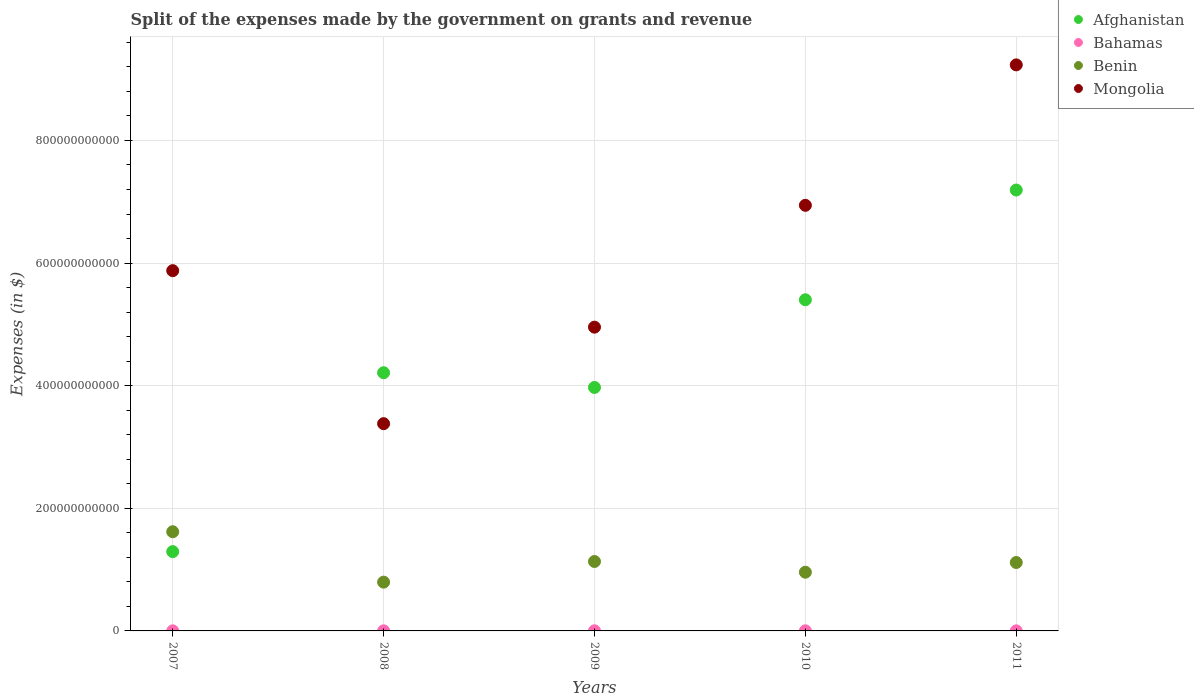How many different coloured dotlines are there?
Provide a succinct answer. 4. What is the expenses made by the government on grants and revenue in Mongolia in 2009?
Offer a very short reply. 4.95e+11. Across all years, what is the maximum expenses made by the government on grants and revenue in Benin?
Offer a very short reply. 1.62e+11. Across all years, what is the minimum expenses made by the government on grants and revenue in Benin?
Provide a short and direct response. 7.96e+1. What is the total expenses made by the government on grants and revenue in Mongolia in the graph?
Your response must be concise. 3.04e+12. What is the difference between the expenses made by the government on grants and revenue in Benin in 2008 and that in 2010?
Give a very brief answer. -1.62e+1. What is the difference between the expenses made by the government on grants and revenue in Afghanistan in 2008 and the expenses made by the government on grants and revenue in Bahamas in 2009?
Keep it short and to the point. 4.21e+11. What is the average expenses made by the government on grants and revenue in Benin per year?
Make the answer very short. 1.12e+11. In the year 2008, what is the difference between the expenses made by the government on grants and revenue in Mongolia and expenses made by the government on grants and revenue in Afghanistan?
Offer a terse response. -8.31e+1. In how many years, is the expenses made by the government on grants and revenue in Benin greater than 800000000000 $?
Offer a very short reply. 0. What is the ratio of the expenses made by the government on grants and revenue in Bahamas in 2007 to that in 2009?
Give a very brief answer. 0.67. What is the difference between the highest and the second highest expenses made by the government on grants and revenue in Afghanistan?
Your response must be concise. 1.79e+11. What is the difference between the highest and the lowest expenses made by the government on grants and revenue in Benin?
Your response must be concise. 8.22e+1. Is it the case that in every year, the sum of the expenses made by the government on grants and revenue in Mongolia and expenses made by the government on grants and revenue in Bahamas  is greater than the expenses made by the government on grants and revenue in Afghanistan?
Keep it short and to the point. No. Is the expenses made by the government on grants and revenue in Bahamas strictly less than the expenses made by the government on grants and revenue in Afghanistan over the years?
Make the answer very short. Yes. How many years are there in the graph?
Ensure brevity in your answer.  5. What is the difference between two consecutive major ticks on the Y-axis?
Make the answer very short. 2.00e+11. Does the graph contain any zero values?
Your answer should be very brief. No. Where does the legend appear in the graph?
Make the answer very short. Top right. How many legend labels are there?
Your answer should be compact. 4. How are the legend labels stacked?
Offer a terse response. Vertical. What is the title of the graph?
Your response must be concise. Split of the expenses made by the government on grants and revenue. Does "West Bank and Gaza" appear as one of the legend labels in the graph?
Your answer should be compact. No. What is the label or title of the X-axis?
Give a very brief answer. Years. What is the label or title of the Y-axis?
Offer a very short reply. Expenses (in $). What is the Expenses (in $) of Afghanistan in 2007?
Make the answer very short. 1.29e+11. What is the Expenses (in $) in Bahamas in 2007?
Give a very brief answer. 1.30e+08. What is the Expenses (in $) of Benin in 2007?
Make the answer very short. 1.62e+11. What is the Expenses (in $) in Mongolia in 2007?
Keep it short and to the point. 5.88e+11. What is the Expenses (in $) of Afghanistan in 2008?
Offer a terse response. 4.21e+11. What is the Expenses (in $) of Bahamas in 2008?
Your answer should be compact. 1.53e+08. What is the Expenses (in $) of Benin in 2008?
Offer a terse response. 7.96e+1. What is the Expenses (in $) of Mongolia in 2008?
Provide a short and direct response. 3.38e+11. What is the Expenses (in $) in Afghanistan in 2009?
Give a very brief answer. 3.97e+11. What is the Expenses (in $) in Bahamas in 2009?
Give a very brief answer. 1.93e+08. What is the Expenses (in $) in Benin in 2009?
Offer a very short reply. 1.13e+11. What is the Expenses (in $) of Mongolia in 2009?
Offer a very short reply. 4.95e+11. What is the Expenses (in $) in Afghanistan in 2010?
Offer a very short reply. 5.40e+11. What is the Expenses (in $) in Bahamas in 2010?
Your answer should be compact. 1.93e+08. What is the Expenses (in $) of Benin in 2010?
Offer a very short reply. 9.58e+1. What is the Expenses (in $) in Mongolia in 2010?
Keep it short and to the point. 6.94e+11. What is the Expenses (in $) in Afghanistan in 2011?
Make the answer very short. 7.19e+11. What is the Expenses (in $) in Bahamas in 2011?
Offer a very short reply. 1.35e+08. What is the Expenses (in $) in Benin in 2011?
Your answer should be compact. 1.12e+11. What is the Expenses (in $) of Mongolia in 2011?
Provide a short and direct response. 9.23e+11. Across all years, what is the maximum Expenses (in $) of Afghanistan?
Make the answer very short. 7.19e+11. Across all years, what is the maximum Expenses (in $) of Bahamas?
Your answer should be compact. 1.93e+08. Across all years, what is the maximum Expenses (in $) in Benin?
Offer a terse response. 1.62e+11. Across all years, what is the maximum Expenses (in $) in Mongolia?
Your response must be concise. 9.23e+11. Across all years, what is the minimum Expenses (in $) of Afghanistan?
Offer a very short reply. 1.29e+11. Across all years, what is the minimum Expenses (in $) of Bahamas?
Ensure brevity in your answer.  1.30e+08. Across all years, what is the minimum Expenses (in $) in Benin?
Your answer should be compact. 7.96e+1. Across all years, what is the minimum Expenses (in $) of Mongolia?
Give a very brief answer. 3.38e+11. What is the total Expenses (in $) of Afghanistan in the graph?
Provide a short and direct response. 2.21e+12. What is the total Expenses (in $) in Bahamas in the graph?
Make the answer very short. 8.04e+08. What is the total Expenses (in $) of Benin in the graph?
Your answer should be compact. 5.62e+11. What is the total Expenses (in $) of Mongolia in the graph?
Keep it short and to the point. 3.04e+12. What is the difference between the Expenses (in $) of Afghanistan in 2007 and that in 2008?
Your answer should be compact. -2.92e+11. What is the difference between the Expenses (in $) of Bahamas in 2007 and that in 2008?
Offer a terse response. -2.28e+07. What is the difference between the Expenses (in $) in Benin in 2007 and that in 2008?
Ensure brevity in your answer.  8.22e+1. What is the difference between the Expenses (in $) of Mongolia in 2007 and that in 2008?
Make the answer very short. 2.50e+11. What is the difference between the Expenses (in $) of Afghanistan in 2007 and that in 2009?
Provide a short and direct response. -2.68e+11. What is the difference between the Expenses (in $) of Bahamas in 2007 and that in 2009?
Offer a terse response. -6.33e+07. What is the difference between the Expenses (in $) of Benin in 2007 and that in 2009?
Provide a short and direct response. 4.85e+1. What is the difference between the Expenses (in $) in Mongolia in 2007 and that in 2009?
Ensure brevity in your answer.  9.22e+1. What is the difference between the Expenses (in $) of Afghanistan in 2007 and that in 2010?
Ensure brevity in your answer.  -4.11e+11. What is the difference between the Expenses (in $) in Bahamas in 2007 and that in 2010?
Keep it short and to the point. -6.31e+07. What is the difference between the Expenses (in $) of Benin in 2007 and that in 2010?
Your answer should be very brief. 6.60e+1. What is the difference between the Expenses (in $) of Mongolia in 2007 and that in 2010?
Offer a very short reply. -1.07e+11. What is the difference between the Expenses (in $) in Afghanistan in 2007 and that in 2011?
Offer a very short reply. -5.90e+11. What is the difference between the Expenses (in $) of Bahamas in 2007 and that in 2011?
Ensure brevity in your answer.  -5.26e+06. What is the difference between the Expenses (in $) in Benin in 2007 and that in 2011?
Provide a succinct answer. 5.02e+1. What is the difference between the Expenses (in $) of Mongolia in 2007 and that in 2011?
Offer a terse response. -3.36e+11. What is the difference between the Expenses (in $) of Afghanistan in 2008 and that in 2009?
Offer a very short reply. 2.40e+1. What is the difference between the Expenses (in $) in Bahamas in 2008 and that in 2009?
Give a very brief answer. -4.05e+07. What is the difference between the Expenses (in $) of Benin in 2008 and that in 2009?
Your answer should be compact. -3.37e+1. What is the difference between the Expenses (in $) in Mongolia in 2008 and that in 2009?
Your answer should be compact. -1.57e+11. What is the difference between the Expenses (in $) of Afghanistan in 2008 and that in 2010?
Provide a short and direct response. -1.19e+11. What is the difference between the Expenses (in $) in Bahamas in 2008 and that in 2010?
Your answer should be compact. -4.03e+07. What is the difference between the Expenses (in $) of Benin in 2008 and that in 2010?
Make the answer very short. -1.62e+1. What is the difference between the Expenses (in $) of Mongolia in 2008 and that in 2010?
Your response must be concise. -3.56e+11. What is the difference between the Expenses (in $) of Afghanistan in 2008 and that in 2011?
Your answer should be compact. -2.98e+11. What is the difference between the Expenses (in $) in Bahamas in 2008 and that in 2011?
Keep it short and to the point. 1.76e+07. What is the difference between the Expenses (in $) in Benin in 2008 and that in 2011?
Make the answer very short. -3.20e+1. What is the difference between the Expenses (in $) in Mongolia in 2008 and that in 2011?
Keep it short and to the point. -5.85e+11. What is the difference between the Expenses (in $) of Afghanistan in 2009 and that in 2010?
Provide a succinct answer. -1.43e+11. What is the difference between the Expenses (in $) in Bahamas in 2009 and that in 2010?
Your answer should be very brief. 1.93e+05. What is the difference between the Expenses (in $) in Benin in 2009 and that in 2010?
Offer a terse response. 1.75e+1. What is the difference between the Expenses (in $) in Mongolia in 2009 and that in 2010?
Give a very brief answer. -1.99e+11. What is the difference between the Expenses (in $) of Afghanistan in 2009 and that in 2011?
Give a very brief answer. -3.22e+11. What is the difference between the Expenses (in $) of Bahamas in 2009 and that in 2011?
Provide a succinct answer. 5.80e+07. What is the difference between the Expenses (in $) in Benin in 2009 and that in 2011?
Your answer should be very brief. 1.68e+09. What is the difference between the Expenses (in $) of Mongolia in 2009 and that in 2011?
Keep it short and to the point. -4.28e+11. What is the difference between the Expenses (in $) of Afghanistan in 2010 and that in 2011?
Keep it short and to the point. -1.79e+11. What is the difference between the Expenses (in $) in Bahamas in 2010 and that in 2011?
Ensure brevity in your answer.  5.79e+07. What is the difference between the Expenses (in $) of Benin in 2010 and that in 2011?
Offer a very short reply. -1.58e+1. What is the difference between the Expenses (in $) in Mongolia in 2010 and that in 2011?
Give a very brief answer. -2.29e+11. What is the difference between the Expenses (in $) in Afghanistan in 2007 and the Expenses (in $) in Bahamas in 2008?
Your answer should be compact. 1.29e+11. What is the difference between the Expenses (in $) in Afghanistan in 2007 and the Expenses (in $) in Benin in 2008?
Offer a terse response. 4.98e+1. What is the difference between the Expenses (in $) of Afghanistan in 2007 and the Expenses (in $) of Mongolia in 2008?
Your answer should be very brief. -2.09e+11. What is the difference between the Expenses (in $) of Bahamas in 2007 and the Expenses (in $) of Benin in 2008?
Offer a terse response. -7.94e+1. What is the difference between the Expenses (in $) of Bahamas in 2007 and the Expenses (in $) of Mongolia in 2008?
Ensure brevity in your answer.  -3.38e+11. What is the difference between the Expenses (in $) in Benin in 2007 and the Expenses (in $) in Mongolia in 2008?
Provide a succinct answer. -1.76e+11. What is the difference between the Expenses (in $) of Afghanistan in 2007 and the Expenses (in $) of Bahamas in 2009?
Your answer should be compact. 1.29e+11. What is the difference between the Expenses (in $) in Afghanistan in 2007 and the Expenses (in $) in Benin in 2009?
Provide a succinct answer. 1.61e+1. What is the difference between the Expenses (in $) of Afghanistan in 2007 and the Expenses (in $) of Mongolia in 2009?
Provide a succinct answer. -3.66e+11. What is the difference between the Expenses (in $) in Bahamas in 2007 and the Expenses (in $) in Benin in 2009?
Your answer should be very brief. -1.13e+11. What is the difference between the Expenses (in $) in Bahamas in 2007 and the Expenses (in $) in Mongolia in 2009?
Offer a very short reply. -4.95e+11. What is the difference between the Expenses (in $) of Benin in 2007 and the Expenses (in $) of Mongolia in 2009?
Offer a very short reply. -3.34e+11. What is the difference between the Expenses (in $) in Afghanistan in 2007 and the Expenses (in $) in Bahamas in 2010?
Give a very brief answer. 1.29e+11. What is the difference between the Expenses (in $) of Afghanistan in 2007 and the Expenses (in $) of Benin in 2010?
Ensure brevity in your answer.  3.36e+1. What is the difference between the Expenses (in $) of Afghanistan in 2007 and the Expenses (in $) of Mongolia in 2010?
Give a very brief answer. -5.65e+11. What is the difference between the Expenses (in $) of Bahamas in 2007 and the Expenses (in $) of Benin in 2010?
Your answer should be compact. -9.56e+1. What is the difference between the Expenses (in $) in Bahamas in 2007 and the Expenses (in $) in Mongolia in 2010?
Your answer should be very brief. -6.94e+11. What is the difference between the Expenses (in $) of Benin in 2007 and the Expenses (in $) of Mongolia in 2010?
Your answer should be very brief. -5.32e+11. What is the difference between the Expenses (in $) in Afghanistan in 2007 and the Expenses (in $) in Bahamas in 2011?
Provide a short and direct response. 1.29e+11. What is the difference between the Expenses (in $) of Afghanistan in 2007 and the Expenses (in $) of Benin in 2011?
Offer a very short reply. 1.78e+1. What is the difference between the Expenses (in $) in Afghanistan in 2007 and the Expenses (in $) in Mongolia in 2011?
Provide a short and direct response. -7.94e+11. What is the difference between the Expenses (in $) of Bahamas in 2007 and the Expenses (in $) of Benin in 2011?
Make the answer very short. -1.11e+11. What is the difference between the Expenses (in $) in Bahamas in 2007 and the Expenses (in $) in Mongolia in 2011?
Your answer should be compact. -9.23e+11. What is the difference between the Expenses (in $) in Benin in 2007 and the Expenses (in $) in Mongolia in 2011?
Give a very brief answer. -7.62e+11. What is the difference between the Expenses (in $) of Afghanistan in 2008 and the Expenses (in $) of Bahamas in 2009?
Offer a very short reply. 4.21e+11. What is the difference between the Expenses (in $) of Afghanistan in 2008 and the Expenses (in $) of Benin in 2009?
Offer a terse response. 3.08e+11. What is the difference between the Expenses (in $) of Afghanistan in 2008 and the Expenses (in $) of Mongolia in 2009?
Make the answer very short. -7.43e+1. What is the difference between the Expenses (in $) in Bahamas in 2008 and the Expenses (in $) in Benin in 2009?
Offer a terse response. -1.13e+11. What is the difference between the Expenses (in $) in Bahamas in 2008 and the Expenses (in $) in Mongolia in 2009?
Provide a short and direct response. -4.95e+11. What is the difference between the Expenses (in $) in Benin in 2008 and the Expenses (in $) in Mongolia in 2009?
Offer a very short reply. -4.16e+11. What is the difference between the Expenses (in $) in Afghanistan in 2008 and the Expenses (in $) in Bahamas in 2010?
Provide a succinct answer. 4.21e+11. What is the difference between the Expenses (in $) in Afghanistan in 2008 and the Expenses (in $) in Benin in 2010?
Your response must be concise. 3.25e+11. What is the difference between the Expenses (in $) of Afghanistan in 2008 and the Expenses (in $) of Mongolia in 2010?
Make the answer very short. -2.73e+11. What is the difference between the Expenses (in $) in Bahamas in 2008 and the Expenses (in $) in Benin in 2010?
Give a very brief answer. -9.56e+1. What is the difference between the Expenses (in $) in Bahamas in 2008 and the Expenses (in $) in Mongolia in 2010?
Provide a short and direct response. -6.94e+11. What is the difference between the Expenses (in $) of Benin in 2008 and the Expenses (in $) of Mongolia in 2010?
Offer a very short reply. -6.15e+11. What is the difference between the Expenses (in $) in Afghanistan in 2008 and the Expenses (in $) in Bahamas in 2011?
Your response must be concise. 4.21e+11. What is the difference between the Expenses (in $) of Afghanistan in 2008 and the Expenses (in $) of Benin in 2011?
Give a very brief answer. 3.10e+11. What is the difference between the Expenses (in $) in Afghanistan in 2008 and the Expenses (in $) in Mongolia in 2011?
Offer a terse response. -5.02e+11. What is the difference between the Expenses (in $) of Bahamas in 2008 and the Expenses (in $) of Benin in 2011?
Ensure brevity in your answer.  -1.11e+11. What is the difference between the Expenses (in $) in Bahamas in 2008 and the Expenses (in $) in Mongolia in 2011?
Your answer should be very brief. -9.23e+11. What is the difference between the Expenses (in $) in Benin in 2008 and the Expenses (in $) in Mongolia in 2011?
Your answer should be very brief. -8.44e+11. What is the difference between the Expenses (in $) in Afghanistan in 2009 and the Expenses (in $) in Bahamas in 2010?
Your answer should be very brief. 3.97e+11. What is the difference between the Expenses (in $) in Afghanistan in 2009 and the Expenses (in $) in Benin in 2010?
Give a very brief answer. 3.01e+11. What is the difference between the Expenses (in $) of Afghanistan in 2009 and the Expenses (in $) of Mongolia in 2010?
Provide a short and direct response. -2.97e+11. What is the difference between the Expenses (in $) in Bahamas in 2009 and the Expenses (in $) in Benin in 2010?
Keep it short and to the point. -9.56e+1. What is the difference between the Expenses (in $) of Bahamas in 2009 and the Expenses (in $) of Mongolia in 2010?
Your answer should be compact. -6.94e+11. What is the difference between the Expenses (in $) of Benin in 2009 and the Expenses (in $) of Mongolia in 2010?
Give a very brief answer. -5.81e+11. What is the difference between the Expenses (in $) of Afghanistan in 2009 and the Expenses (in $) of Bahamas in 2011?
Offer a very short reply. 3.97e+11. What is the difference between the Expenses (in $) in Afghanistan in 2009 and the Expenses (in $) in Benin in 2011?
Your answer should be compact. 2.86e+11. What is the difference between the Expenses (in $) in Afghanistan in 2009 and the Expenses (in $) in Mongolia in 2011?
Provide a short and direct response. -5.26e+11. What is the difference between the Expenses (in $) of Bahamas in 2009 and the Expenses (in $) of Benin in 2011?
Give a very brief answer. -1.11e+11. What is the difference between the Expenses (in $) of Bahamas in 2009 and the Expenses (in $) of Mongolia in 2011?
Your answer should be compact. -9.23e+11. What is the difference between the Expenses (in $) in Benin in 2009 and the Expenses (in $) in Mongolia in 2011?
Keep it short and to the point. -8.10e+11. What is the difference between the Expenses (in $) of Afghanistan in 2010 and the Expenses (in $) of Bahamas in 2011?
Make the answer very short. 5.40e+11. What is the difference between the Expenses (in $) of Afghanistan in 2010 and the Expenses (in $) of Benin in 2011?
Give a very brief answer. 4.29e+11. What is the difference between the Expenses (in $) of Afghanistan in 2010 and the Expenses (in $) of Mongolia in 2011?
Make the answer very short. -3.83e+11. What is the difference between the Expenses (in $) in Bahamas in 2010 and the Expenses (in $) in Benin in 2011?
Make the answer very short. -1.11e+11. What is the difference between the Expenses (in $) in Bahamas in 2010 and the Expenses (in $) in Mongolia in 2011?
Keep it short and to the point. -9.23e+11. What is the difference between the Expenses (in $) of Benin in 2010 and the Expenses (in $) of Mongolia in 2011?
Provide a succinct answer. -8.28e+11. What is the average Expenses (in $) of Afghanistan per year?
Provide a succinct answer. 4.41e+11. What is the average Expenses (in $) in Bahamas per year?
Offer a terse response. 1.61e+08. What is the average Expenses (in $) of Benin per year?
Offer a very short reply. 1.12e+11. What is the average Expenses (in $) of Mongolia per year?
Keep it short and to the point. 6.08e+11. In the year 2007, what is the difference between the Expenses (in $) of Afghanistan and Expenses (in $) of Bahamas?
Provide a succinct answer. 1.29e+11. In the year 2007, what is the difference between the Expenses (in $) of Afghanistan and Expenses (in $) of Benin?
Your answer should be compact. -3.24e+1. In the year 2007, what is the difference between the Expenses (in $) in Afghanistan and Expenses (in $) in Mongolia?
Provide a short and direct response. -4.58e+11. In the year 2007, what is the difference between the Expenses (in $) in Bahamas and Expenses (in $) in Benin?
Give a very brief answer. -1.62e+11. In the year 2007, what is the difference between the Expenses (in $) of Bahamas and Expenses (in $) of Mongolia?
Your answer should be very brief. -5.87e+11. In the year 2007, what is the difference between the Expenses (in $) in Benin and Expenses (in $) in Mongolia?
Your response must be concise. -4.26e+11. In the year 2008, what is the difference between the Expenses (in $) of Afghanistan and Expenses (in $) of Bahamas?
Your answer should be compact. 4.21e+11. In the year 2008, what is the difference between the Expenses (in $) of Afghanistan and Expenses (in $) of Benin?
Your response must be concise. 3.42e+11. In the year 2008, what is the difference between the Expenses (in $) of Afghanistan and Expenses (in $) of Mongolia?
Give a very brief answer. 8.31e+1. In the year 2008, what is the difference between the Expenses (in $) of Bahamas and Expenses (in $) of Benin?
Offer a very short reply. -7.94e+1. In the year 2008, what is the difference between the Expenses (in $) of Bahamas and Expenses (in $) of Mongolia?
Provide a short and direct response. -3.38e+11. In the year 2008, what is the difference between the Expenses (in $) of Benin and Expenses (in $) of Mongolia?
Give a very brief answer. -2.58e+11. In the year 2009, what is the difference between the Expenses (in $) of Afghanistan and Expenses (in $) of Bahamas?
Your answer should be very brief. 3.97e+11. In the year 2009, what is the difference between the Expenses (in $) of Afghanistan and Expenses (in $) of Benin?
Offer a very short reply. 2.84e+11. In the year 2009, what is the difference between the Expenses (in $) of Afghanistan and Expenses (in $) of Mongolia?
Your response must be concise. -9.83e+1. In the year 2009, what is the difference between the Expenses (in $) in Bahamas and Expenses (in $) in Benin?
Your answer should be very brief. -1.13e+11. In the year 2009, what is the difference between the Expenses (in $) of Bahamas and Expenses (in $) of Mongolia?
Keep it short and to the point. -4.95e+11. In the year 2009, what is the difference between the Expenses (in $) in Benin and Expenses (in $) in Mongolia?
Offer a terse response. -3.82e+11. In the year 2010, what is the difference between the Expenses (in $) in Afghanistan and Expenses (in $) in Bahamas?
Give a very brief answer. 5.40e+11. In the year 2010, what is the difference between the Expenses (in $) of Afghanistan and Expenses (in $) of Benin?
Give a very brief answer. 4.44e+11. In the year 2010, what is the difference between the Expenses (in $) in Afghanistan and Expenses (in $) in Mongolia?
Provide a short and direct response. -1.54e+11. In the year 2010, what is the difference between the Expenses (in $) in Bahamas and Expenses (in $) in Benin?
Your response must be concise. -9.56e+1. In the year 2010, what is the difference between the Expenses (in $) in Bahamas and Expenses (in $) in Mongolia?
Give a very brief answer. -6.94e+11. In the year 2010, what is the difference between the Expenses (in $) of Benin and Expenses (in $) of Mongolia?
Provide a short and direct response. -5.98e+11. In the year 2011, what is the difference between the Expenses (in $) of Afghanistan and Expenses (in $) of Bahamas?
Keep it short and to the point. 7.19e+11. In the year 2011, what is the difference between the Expenses (in $) of Afghanistan and Expenses (in $) of Benin?
Make the answer very short. 6.08e+11. In the year 2011, what is the difference between the Expenses (in $) of Afghanistan and Expenses (in $) of Mongolia?
Offer a terse response. -2.04e+11. In the year 2011, what is the difference between the Expenses (in $) of Bahamas and Expenses (in $) of Benin?
Make the answer very short. -1.11e+11. In the year 2011, what is the difference between the Expenses (in $) of Bahamas and Expenses (in $) of Mongolia?
Keep it short and to the point. -9.23e+11. In the year 2011, what is the difference between the Expenses (in $) of Benin and Expenses (in $) of Mongolia?
Keep it short and to the point. -8.12e+11. What is the ratio of the Expenses (in $) of Afghanistan in 2007 to that in 2008?
Your response must be concise. 0.31. What is the ratio of the Expenses (in $) in Bahamas in 2007 to that in 2008?
Your answer should be very brief. 0.85. What is the ratio of the Expenses (in $) of Benin in 2007 to that in 2008?
Keep it short and to the point. 2.03. What is the ratio of the Expenses (in $) of Mongolia in 2007 to that in 2008?
Your answer should be very brief. 1.74. What is the ratio of the Expenses (in $) of Afghanistan in 2007 to that in 2009?
Provide a succinct answer. 0.33. What is the ratio of the Expenses (in $) of Bahamas in 2007 to that in 2009?
Your answer should be compact. 0.67. What is the ratio of the Expenses (in $) of Benin in 2007 to that in 2009?
Offer a terse response. 1.43. What is the ratio of the Expenses (in $) in Mongolia in 2007 to that in 2009?
Your answer should be compact. 1.19. What is the ratio of the Expenses (in $) in Afghanistan in 2007 to that in 2010?
Provide a short and direct response. 0.24. What is the ratio of the Expenses (in $) of Bahamas in 2007 to that in 2010?
Your answer should be compact. 0.67. What is the ratio of the Expenses (in $) of Benin in 2007 to that in 2010?
Keep it short and to the point. 1.69. What is the ratio of the Expenses (in $) in Mongolia in 2007 to that in 2010?
Your answer should be compact. 0.85. What is the ratio of the Expenses (in $) in Afghanistan in 2007 to that in 2011?
Offer a terse response. 0.18. What is the ratio of the Expenses (in $) of Bahamas in 2007 to that in 2011?
Keep it short and to the point. 0.96. What is the ratio of the Expenses (in $) of Benin in 2007 to that in 2011?
Your answer should be very brief. 1.45. What is the ratio of the Expenses (in $) of Mongolia in 2007 to that in 2011?
Your answer should be very brief. 0.64. What is the ratio of the Expenses (in $) of Afghanistan in 2008 to that in 2009?
Your answer should be very brief. 1.06. What is the ratio of the Expenses (in $) in Bahamas in 2008 to that in 2009?
Offer a very short reply. 0.79. What is the ratio of the Expenses (in $) of Benin in 2008 to that in 2009?
Give a very brief answer. 0.7. What is the ratio of the Expenses (in $) in Mongolia in 2008 to that in 2009?
Provide a succinct answer. 0.68. What is the ratio of the Expenses (in $) in Afghanistan in 2008 to that in 2010?
Your answer should be compact. 0.78. What is the ratio of the Expenses (in $) in Bahamas in 2008 to that in 2010?
Your answer should be very brief. 0.79. What is the ratio of the Expenses (in $) of Benin in 2008 to that in 2010?
Keep it short and to the point. 0.83. What is the ratio of the Expenses (in $) in Mongolia in 2008 to that in 2010?
Keep it short and to the point. 0.49. What is the ratio of the Expenses (in $) in Afghanistan in 2008 to that in 2011?
Provide a succinct answer. 0.59. What is the ratio of the Expenses (in $) in Bahamas in 2008 to that in 2011?
Make the answer very short. 1.13. What is the ratio of the Expenses (in $) of Benin in 2008 to that in 2011?
Your response must be concise. 0.71. What is the ratio of the Expenses (in $) in Mongolia in 2008 to that in 2011?
Your answer should be very brief. 0.37. What is the ratio of the Expenses (in $) in Afghanistan in 2009 to that in 2010?
Keep it short and to the point. 0.74. What is the ratio of the Expenses (in $) of Bahamas in 2009 to that in 2010?
Provide a succinct answer. 1. What is the ratio of the Expenses (in $) of Benin in 2009 to that in 2010?
Your answer should be compact. 1.18. What is the ratio of the Expenses (in $) in Mongolia in 2009 to that in 2010?
Offer a terse response. 0.71. What is the ratio of the Expenses (in $) of Afghanistan in 2009 to that in 2011?
Provide a short and direct response. 0.55. What is the ratio of the Expenses (in $) of Bahamas in 2009 to that in 2011?
Offer a terse response. 1.43. What is the ratio of the Expenses (in $) in Benin in 2009 to that in 2011?
Give a very brief answer. 1.02. What is the ratio of the Expenses (in $) of Mongolia in 2009 to that in 2011?
Make the answer very short. 0.54. What is the ratio of the Expenses (in $) in Afghanistan in 2010 to that in 2011?
Offer a terse response. 0.75. What is the ratio of the Expenses (in $) in Bahamas in 2010 to that in 2011?
Give a very brief answer. 1.43. What is the ratio of the Expenses (in $) in Benin in 2010 to that in 2011?
Make the answer very short. 0.86. What is the ratio of the Expenses (in $) of Mongolia in 2010 to that in 2011?
Give a very brief answer. 0.75. What is the difference between the highest and the second highest Expenses (in $) of Afghanistan?
Give a very brief answer. 1.79e+11. What is the difference between the highest and the second highest Expenses (in $) of Bahamas?
Offer a very short reply. 1.93e+05. What is the difference between the highest and the second highest Expenses (in $) in Benin?
Your response must be concise. 4.85e+1. What is the difference between the highest and the second highest Expenses (in $) of Mongolia?
Offer a terse response. 2.29e+11. What is the difference between the highest and the lowest Expenses (in $) of Afghanistan?
Your answer should be very brief. 5.90e+11. What is the difference between the highest and the lowest Expenses (in $) of Bahamas?
Keep it short and to the point. 6.33e+07. What is the difference between the highest and the lowest Expenses (in $) of Benin?
Keep it short and to the point. 8.22e+1. What is the difference between the highest and the lowest Expenses (in $) of Mongolia?
Your answer should be very brief. 5.85e+11. 